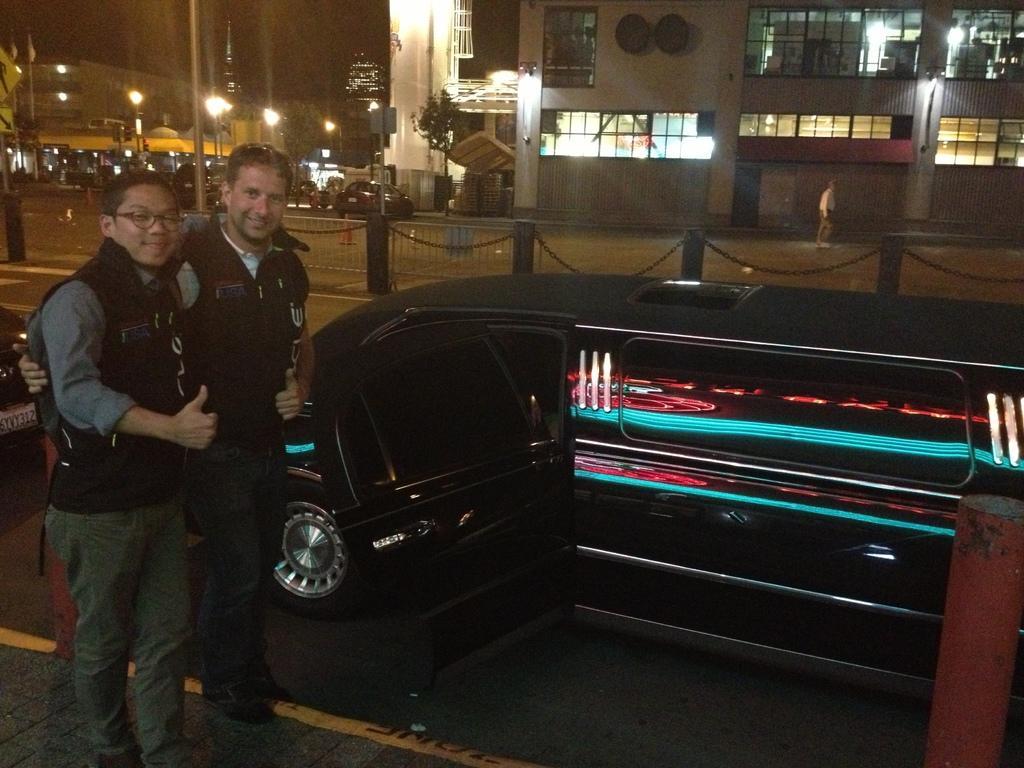Please provide a concise description of this image. In this image we can see men standing on the road, motor vehicles on the road, grills, barrier poles, buildings, electric lights, street poles, street lights and bins on the road. 